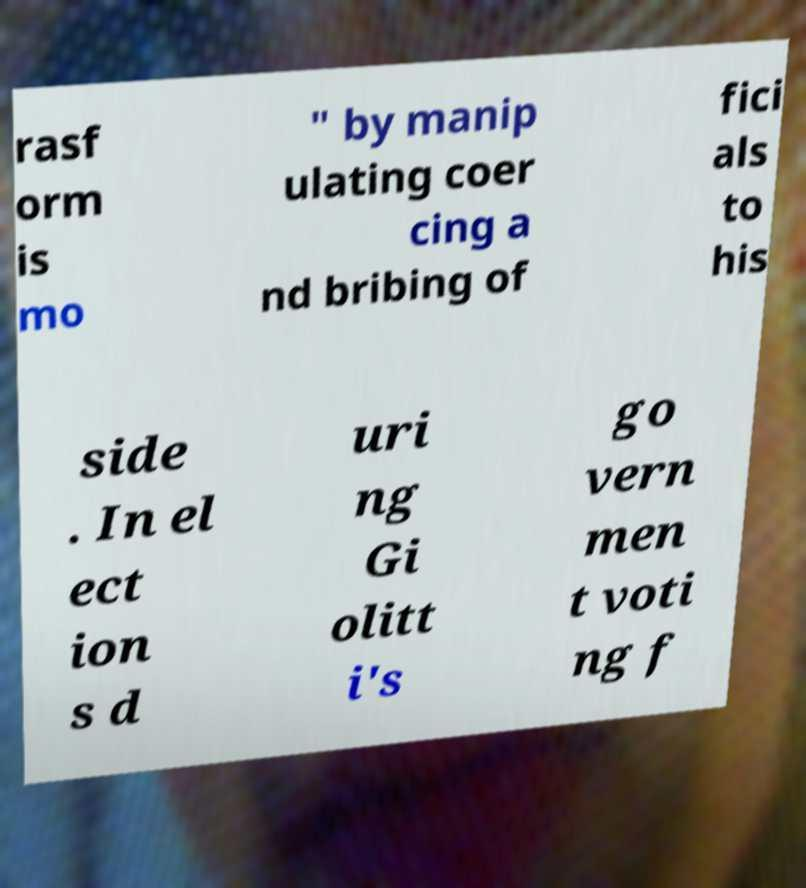Can you read and provide the text displayed in the image?This photo seems to have some interesting text. Can you extract and type it out for me? rasf orm is mo " by manip ulating coer cing a nd bribing of fici als to his side . In el ect ion s d uri ng Gi olitt i's go vern men t voti ng f 